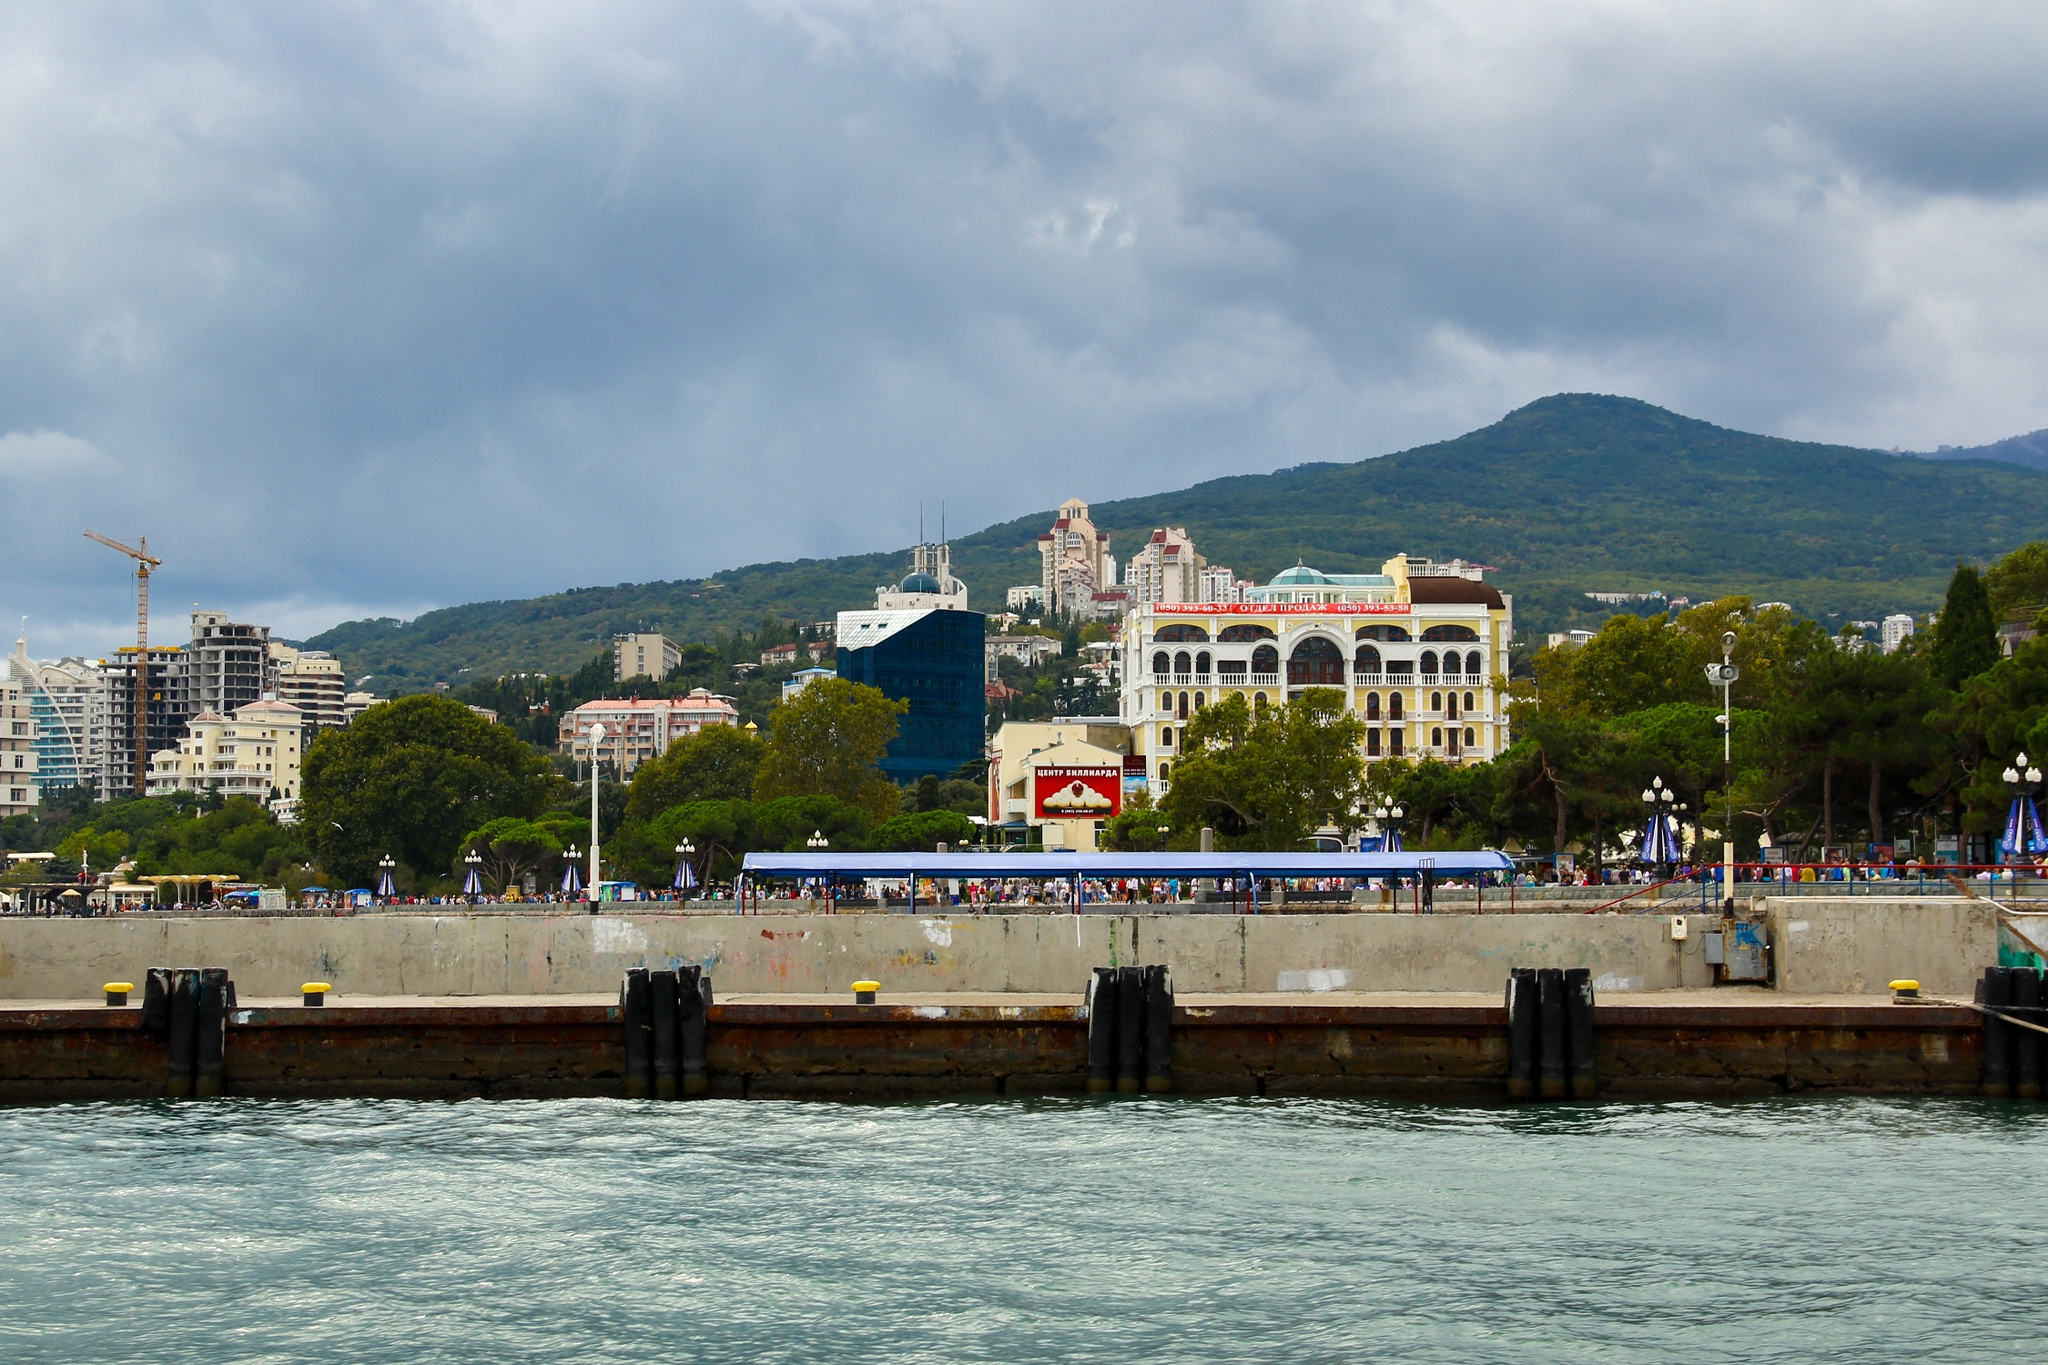Craft a detailed and elaborate historical narrative involving the location. The Yalta seafront is steeped in history, going back centuries when it was a quiet coastal village. In the early 19th century, Tsar Alexander I recognized the region's potential and began developing it as a premier retreat for Russian nobility. The grand white building with the red roof, known as the Imperial Pavilion, was constructed to host lavish gatherings and royal events. It became a symbol of the Golden Age of Yalta, attracting dignitaries, artists, and intellectuals from all over Europe. The blue building with the green roof initially served as the Yalta Observatory, playing a crucial role in 19th-century maritime navigation and cosmic studies. Throughout the 20th century, Yalta witnessed political upheavals and transformations. The historic Yalta Conference in 1945, held at the nearby Livadia Palace, marked a pivotal point in world history, shaping the post-World War II order. Today, while modern developments have emerged, the area retains its historic charm, with each building telling a story of its glorious past. The blend of history and modernity makes Yalta's seafront a timeless and fascinating destination. 